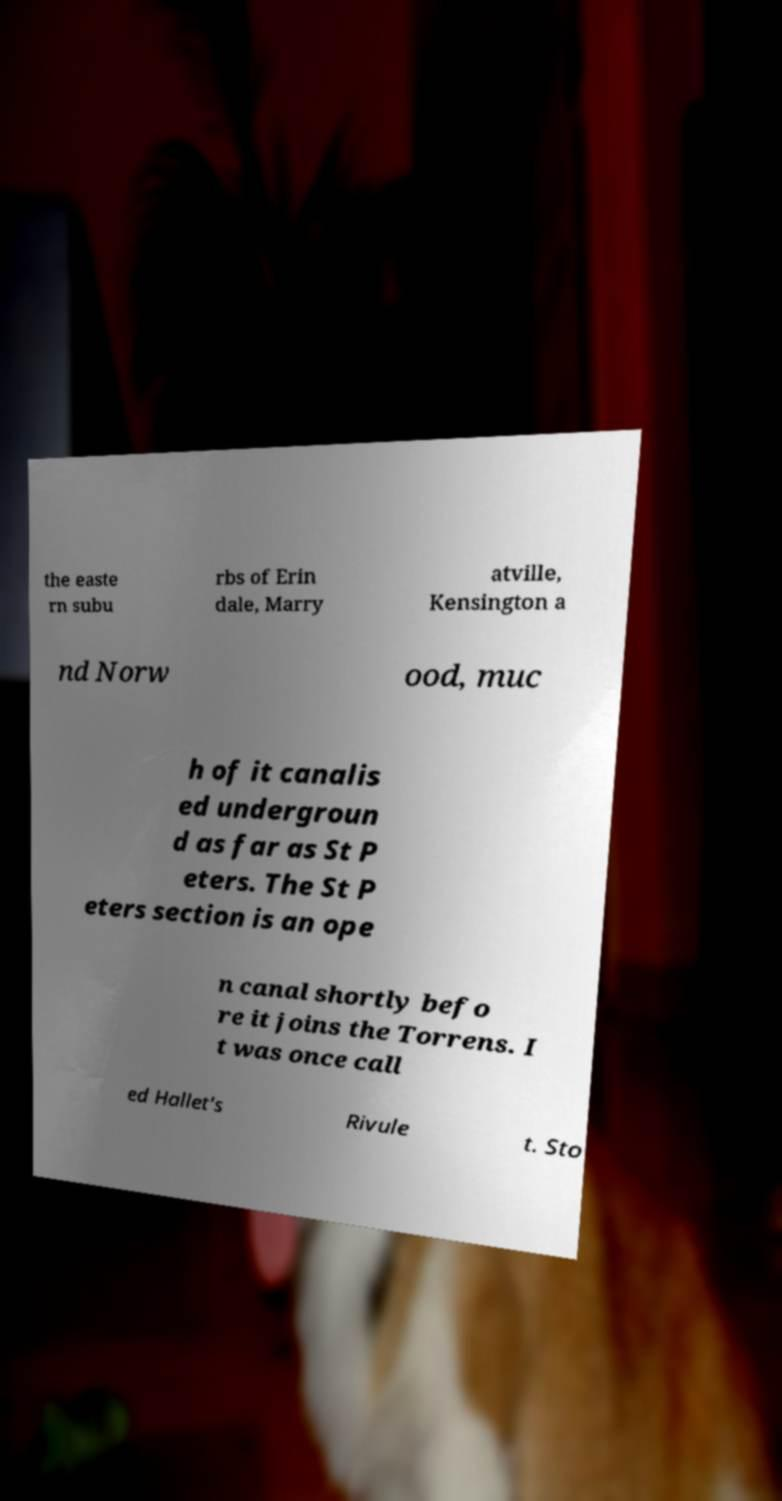Could you assist in decoding the text presented in this image and type it out clearly? the easte rn subu rbs of Erin dale, Marry atville, Kensington a nd Norw ood, muc h of it canalis ed undergroun d as far as St P eters. The St P eters section is an ope n canal shortly befo re it joins the Torrens. I t was once call ed Hallet's Rivule t. Sto 